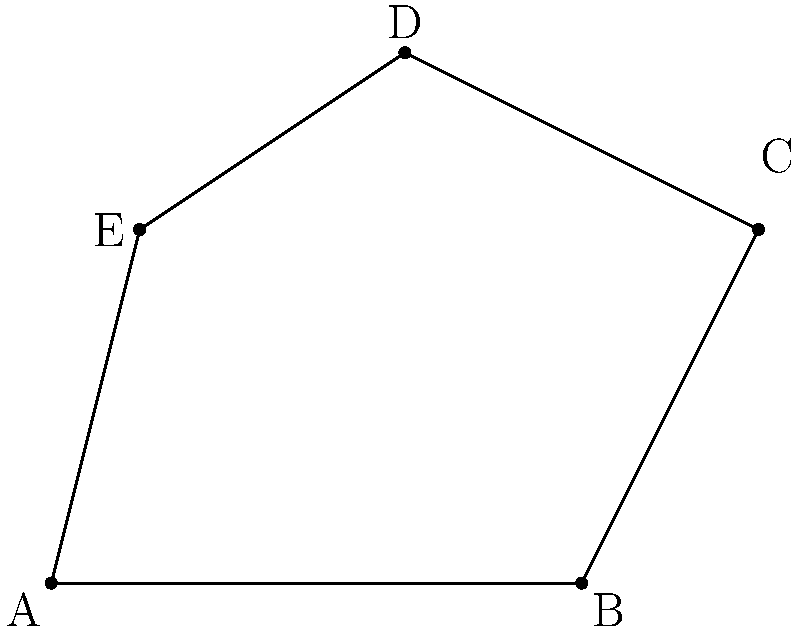In a defensive formation, five players are positioned at points A(0,0), B(6,0), C(8,4), D(4,6), and E(1,4) on a coordinate plane. Calculate the area of the irregular polygon formed by connecting these points. Round your answer to the nearest square unit. To calculate the area of this irregular polygon, we can use the Shoelace formula (also known as the surveyor's formula). This method is particularly useful for polygons with known vertex coordinates.

The Shoelace formula states:

$$ Area = \frac{1}{2}|(x_1y_2 + x_2y_3 + ... + x_ny_1) - (y_1x_2 + y_2x_3 + ... + y_nx_1)|$$

Where $(x_i, y_i)$ are the coordinates of the $i$-th vertex.

Let's apply this formula to our polygon:

1) First, list the coordinates in order:
   A(0,0), B(6,0), C(8,4), D(4,6), E(1,4)

2) Apply the formula:
   $$ \begin{align*}
   Area &= \frac{1}{2}|(0 \cdot 0 + 6 \cdot 4 + 8 \cdot 6 + 4 \cdot 4 + 1 \cdot 0) \\
   &\quad - (0 \cdot 6 + 0 \cdot 8 + 4 \cdot 4 + 6 \cdot 1 + 4 \cdot 0)| \\
   &= \frac{1}{2}|(0 + 24 + 48 + 16 + 0) - (0 + 0 + 16 + 6 + 0)| \\
   &= \frac{1}{2}|88 - 22| \\
   &= \frac{1}{2} \cdot 66 \\
   &= 33
   \end{align*} $$

3) The exact area is 33 square units.

4) Rounding to the nearest square unit: 33 square units.

This method allows us to calculate the area efficiently without decomposing the polygon into simpler shapes, demonstrating composure and consistency in problem-solving.
Answer: 33 square units 